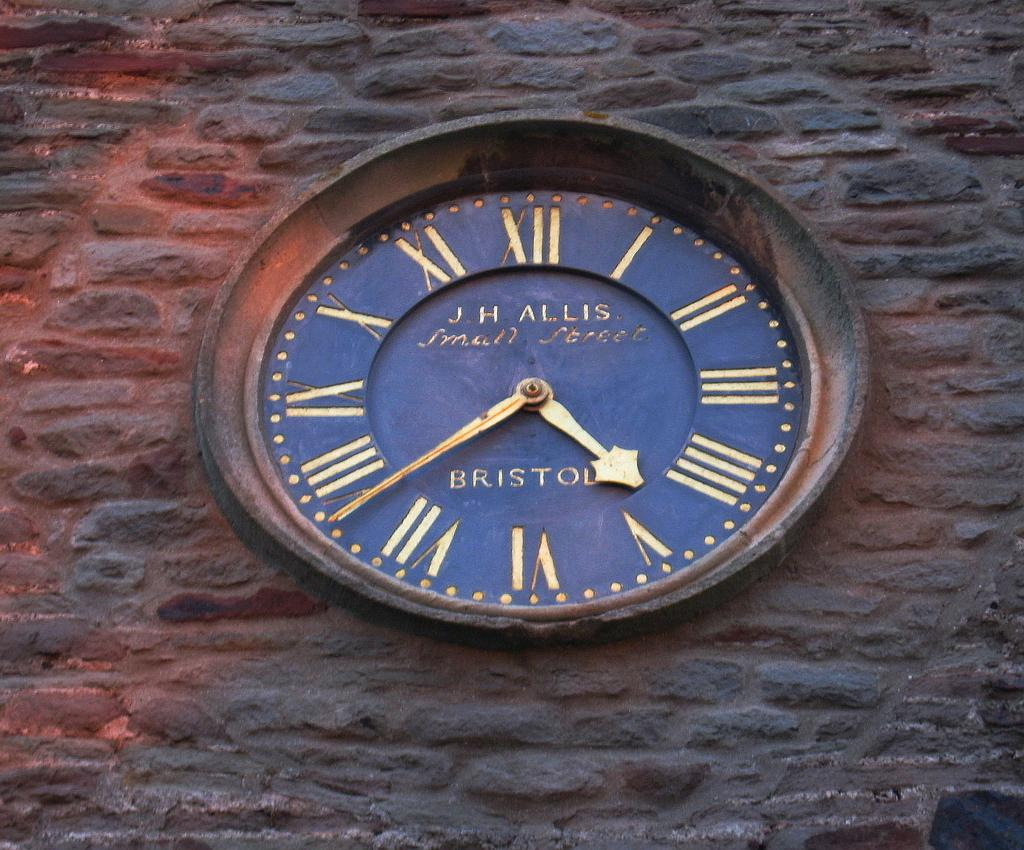<image>
Write a terse but informative summary of the picture. A blue and gold clock that says JH Allis on the front of it. 